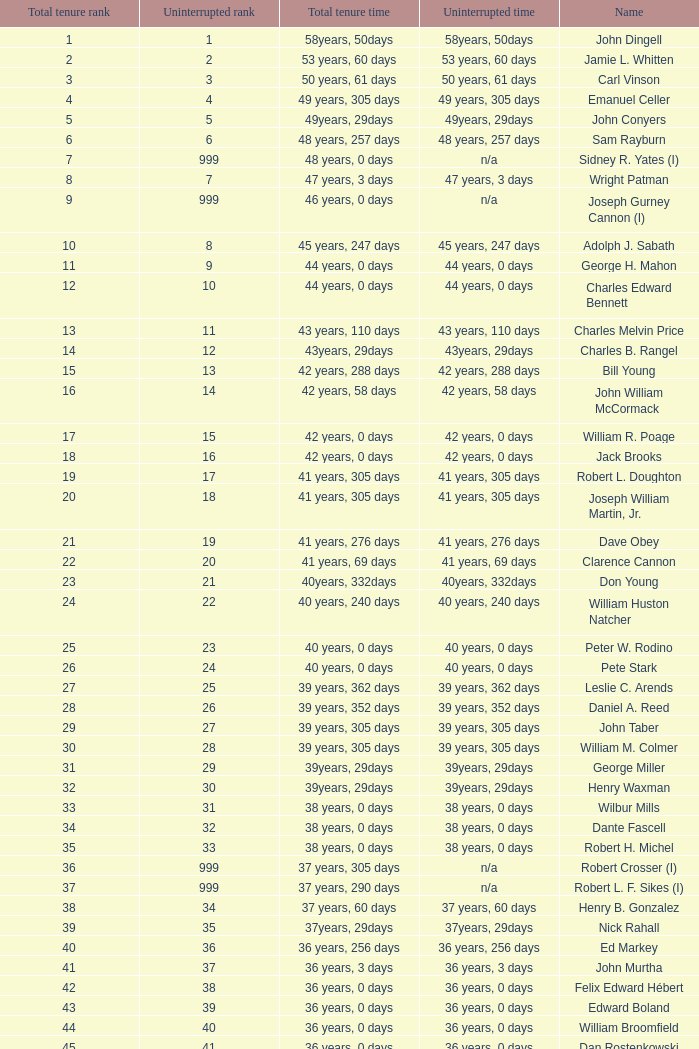Who has a total tenure time and uninterrupted time of 36 years, 0 days, as well as a total tenure rank of 49? James Oberstar. 